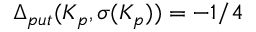Convert formula to latex. <formula><loc_0><loc_0><loc_500><loc_500>\Delta _ { p u t } ( K _ { p } , \sigma ( K _ { p } ) ) = - 1 / 4</formula> 